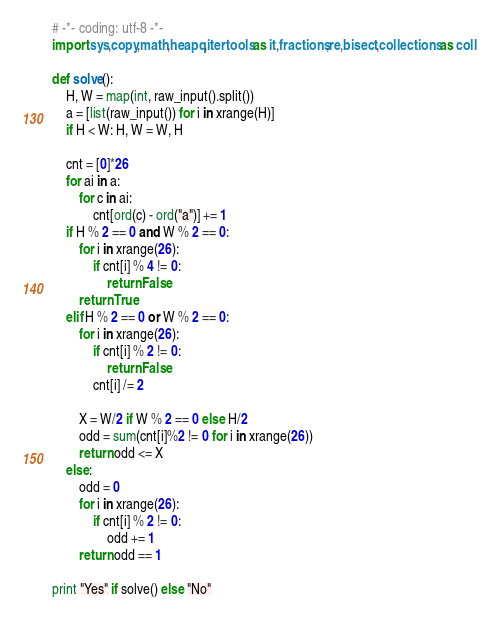Convert code to text. <code><loc_0><loc_0><loc_500><loc_500><_Python_># -*- coding: utf-8 -*-
import sys,copy,math,heapq,itertools as it,fractions,re,bisect,collections as coll

def solve():
    H, W = map(int, raw_input().split())
    a = [list(raw_input()) for i in xrange(H)]
    if H < W: H, W = W, H

    cnt = [0]*26
    for ai in a:
        for c in ai:
            cnt[ord(c) - ord("a")] += 1
    if H % 2 == 0 and W % 2 == 0:
        for i in xrange(26):
            if cnt[i] % 4 != 0:
                return False
        return True
    elif H % 2 == 0 or W % 2 == 0:
        for i in xrange(26):
            if cnt[i] % 2 != 0:
                return False
            cnt[i] /= 2

        X = W/2 if W % 2 == 0 else H/2
        odd = sum(cnt[i]%2 != 0 for i in xrange(26)) 
        return odd <= X 
    else:
        odd = 0
        for i in xrange(26):
            if cnt[i] % 2 != 0:
                odd += 1
        return odd == 1

print "Yes" if solve() else "No"
</code> 